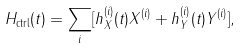Convert formula to latex. <formula><loc_0><loc_0><loc_500><loc_500>H _ { \text {ctrl} } ( t ) = \sum _ { i } [ h _ { X } ^ { ( i ) } ( t ) X ^ { ( i ) } + h _ { Y } ^ { ( i ) } ( t ) Y ^ { ( i ) } ] ,</formula> 